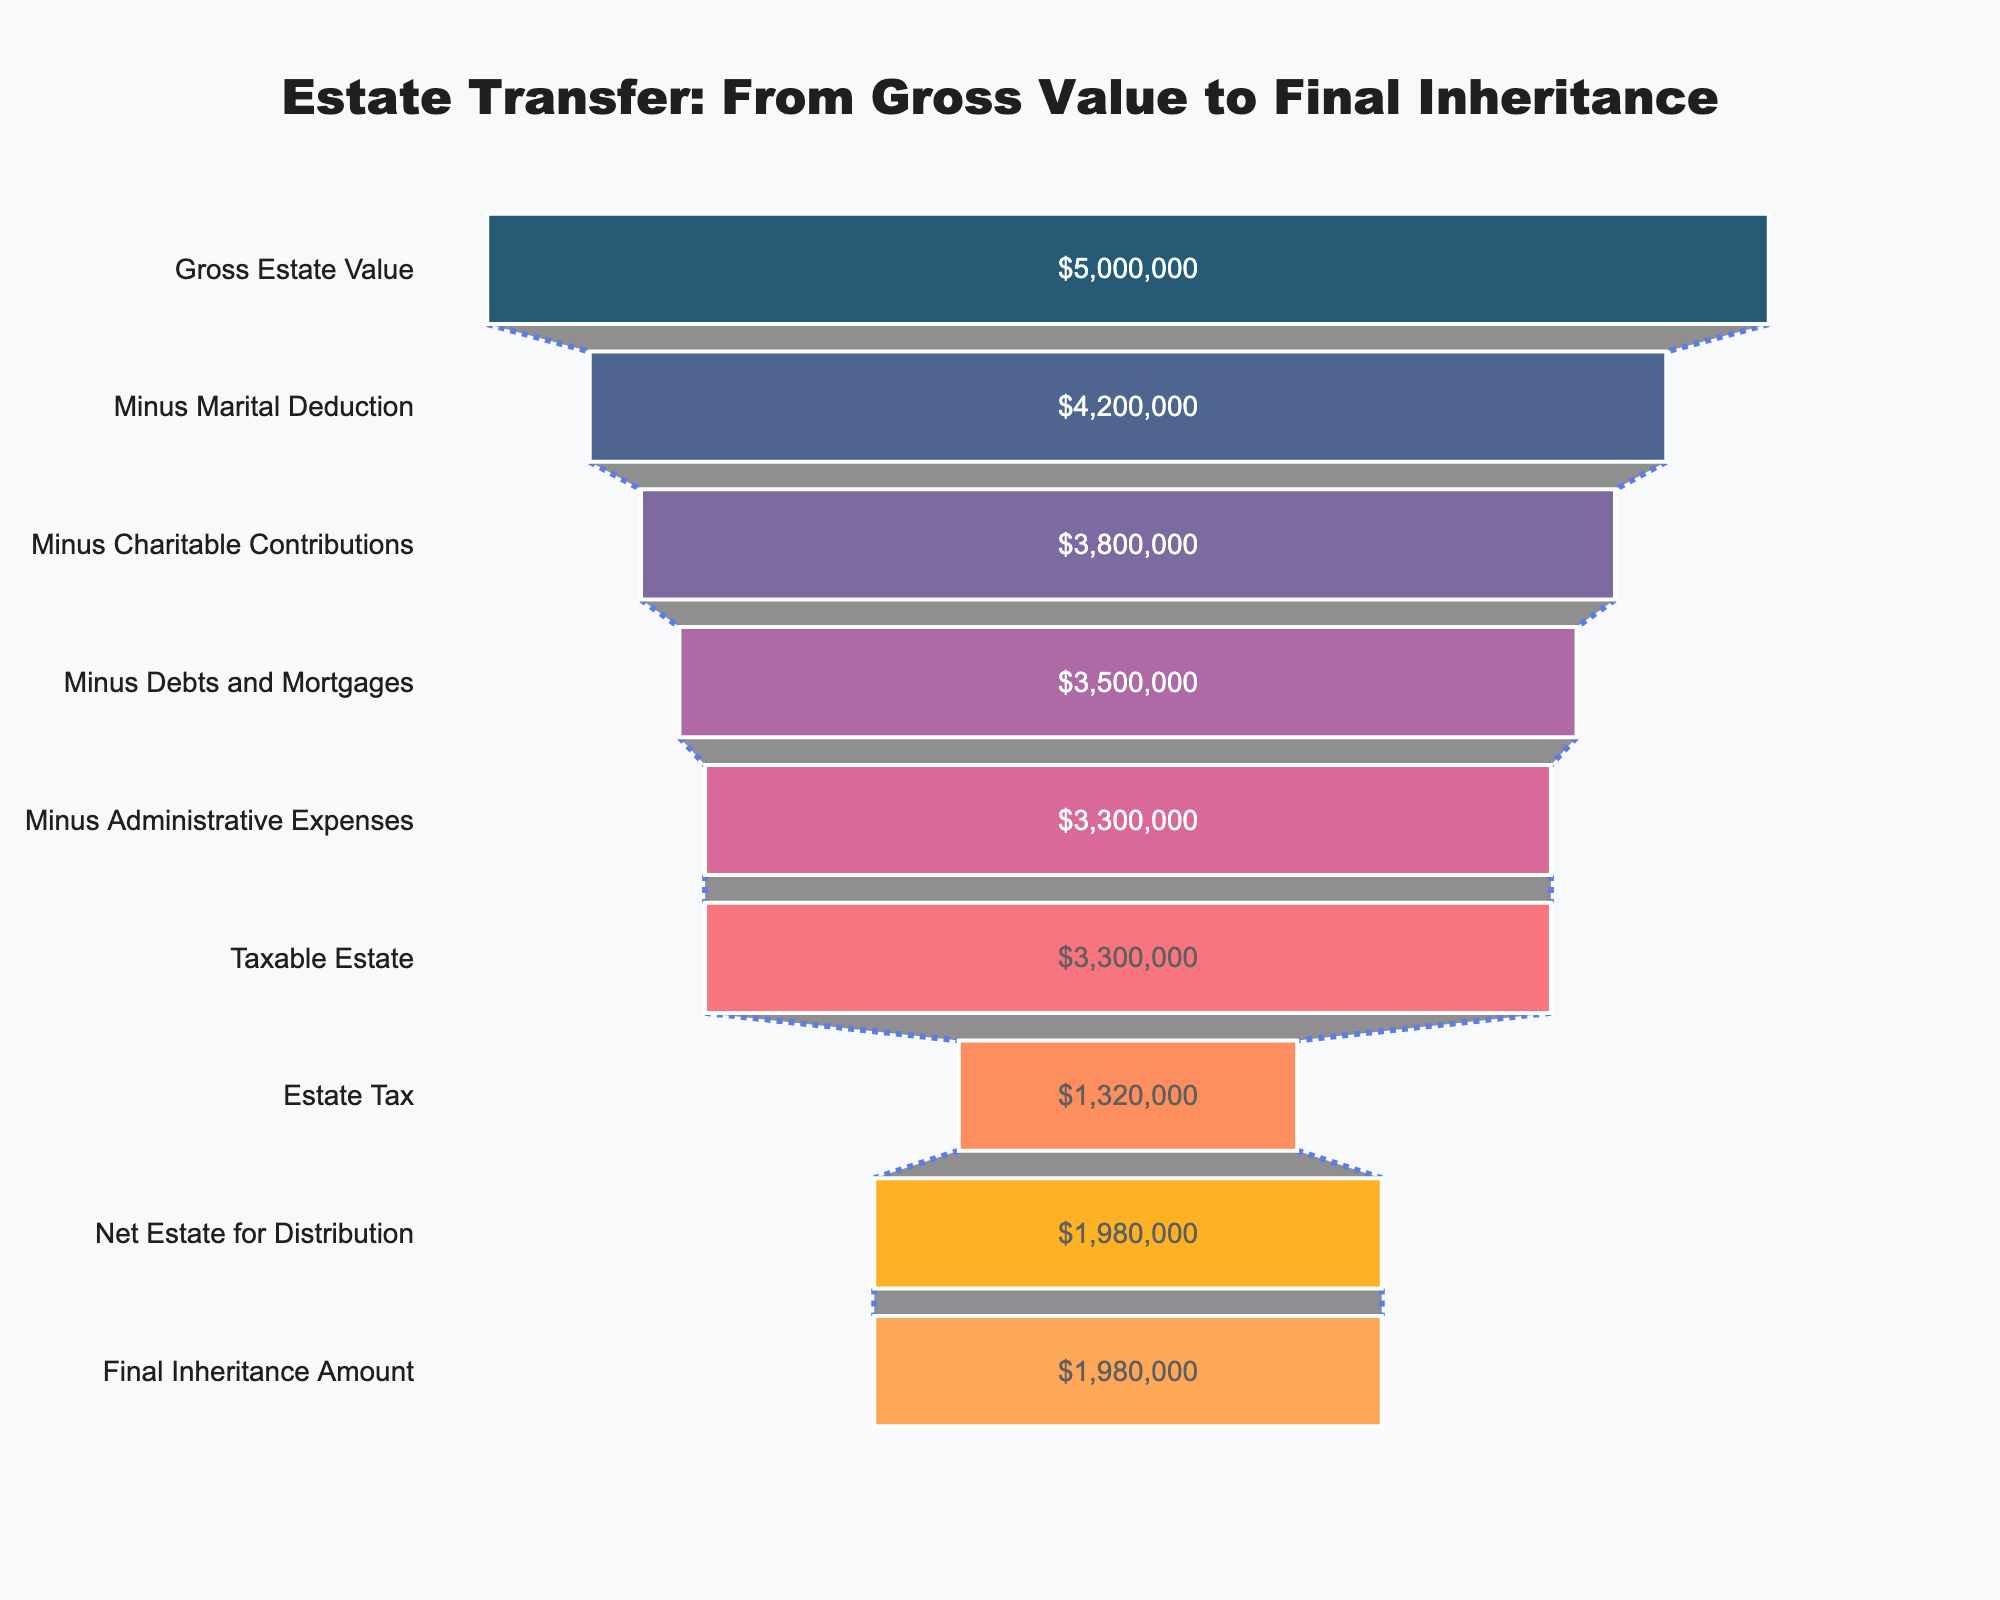What is the title of the funnel chart? The title is usually displayed at the top of the chart and provides a summary of what the chart represents.
Answer: Estate Transfer: From Gross Value to Final Inheritance What is the value of the taxable estate? Find the stage labeled "Taxable Estate" in the funnel chart, and refer to the value displayed beside it.
Answer: $3,300,000 How much is subtracted as the marital deduction? Look at the stage labeled "Minus Marital Deduction" and check the value shown. Subtract this from the previous stage to get the marital deduction amount.
Answer: $800,000 What percentage of the gross estate value is the final inheritance amount? Take the final inheritance amount ($1,980,000) and divide it by the gross estate value ($5,000,000). Multiply by 100 to get the percentage.
Answer: 39.6% Compare the taxable estate to the net estate for distribution. Look at the values for "Taxable Estate" and "Net Estate for Distribution." Subtract the net estate value from the taxable estate value.
Answer: $1,320,000 What is the combined total of debts and mortgages and administrative expenses? Add the values for "Minus Debts and Mortgages" and "Minus Administrative Expenses."
Answer: $200,000 How do charitable contributions affect the estate value? Note the difference between the value at "Minus Marital Deduction" ($4,200,000) and "Minus Charitable Contributions" ($3,800,000). This difference represents the impact of charitable contributions.
Answer: $400,000 Which stage has the largest reduction in value in the funnel? Compare the differences in values between successive stages. The stage with the largest difference represents the largest reduction.
Answer: Marital Deduction ($800,000 reduction) What is the estate tax, and how is it calculated from the taxable estate? The estate tax value is provided directly at the "Estate Tax" stage ($1,320,000). It is often a percentage of the taxable estate. Check the relationship between $3,300,000 and $1,320,000 (usually a set rate).
Answer: $1,320,000 How much is the final inheritance amount after all deductions and taxes? Reference the final stage labeled "Final Inheritance Amount" to find the value.
Answer: $1,980,000 